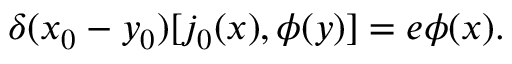Convert formula to latex. <formula><loc_0><loc_0><loc_500><loc_500>\delta ( x _ { 0 } - y _ { 0 } ) [ j _ { 0 } ( x ) , \phi ( y ) ] = e \phi ( x ) .</formula> 